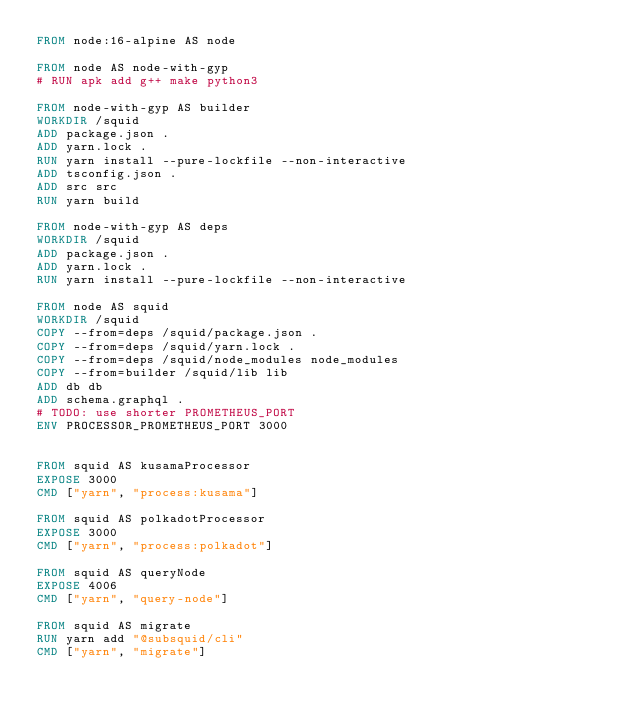<code> <loc_0><loc_0><loc_500><loc_500><_Dockerfile_>FROM node:16-alpine AS node

FROM node AS node-with-gyp
# RUN apk add g++ make python3

FROM node-with-gyp AS builder
WORKDIR /squid
ADD package.json .
ADD yarn.lock .
RUN yarn install --pure-lockfile --non-interactive
ADD tsconfig.json .
ADD src src
RUN yarn build

FROM node-with-gyp AS deps
WORKDIR /squid
ADD package.json .
ADD yarn.lock .
RUN yarn install --pure-lockfile --non-interactive

FROM node AS squid
WORKDIR /squid
COPY --from=deps /squid/package.json .
COPY --from=deps /squid/yarn.lock .
COPY --from=deps /squid/node_modules node_modules
COPY --from=builder /squid/lib lib
ADD db db
ADD schema.graphql .
# TODO: use shorter PROMETHEUS_PORT
ENV PROCESSOR_PROMETHEUS_PORT 3000


FROM squid AS kusamaProcessor
EXPOSE 3000
CMD ["yarn", "process:kusama"]

FROM squid AS polkadotProcessor
EXPOSE 3000
CMD ["yarn", "process:polkadot"]

FROM squid AS queryNode
EXPOSE 4006
CMD ["yarn", "query-node"]

FROM squid AS migrate
RUN yarn add "@subsquid/cli"
CMD ["yarn", "migrate"]</code> 